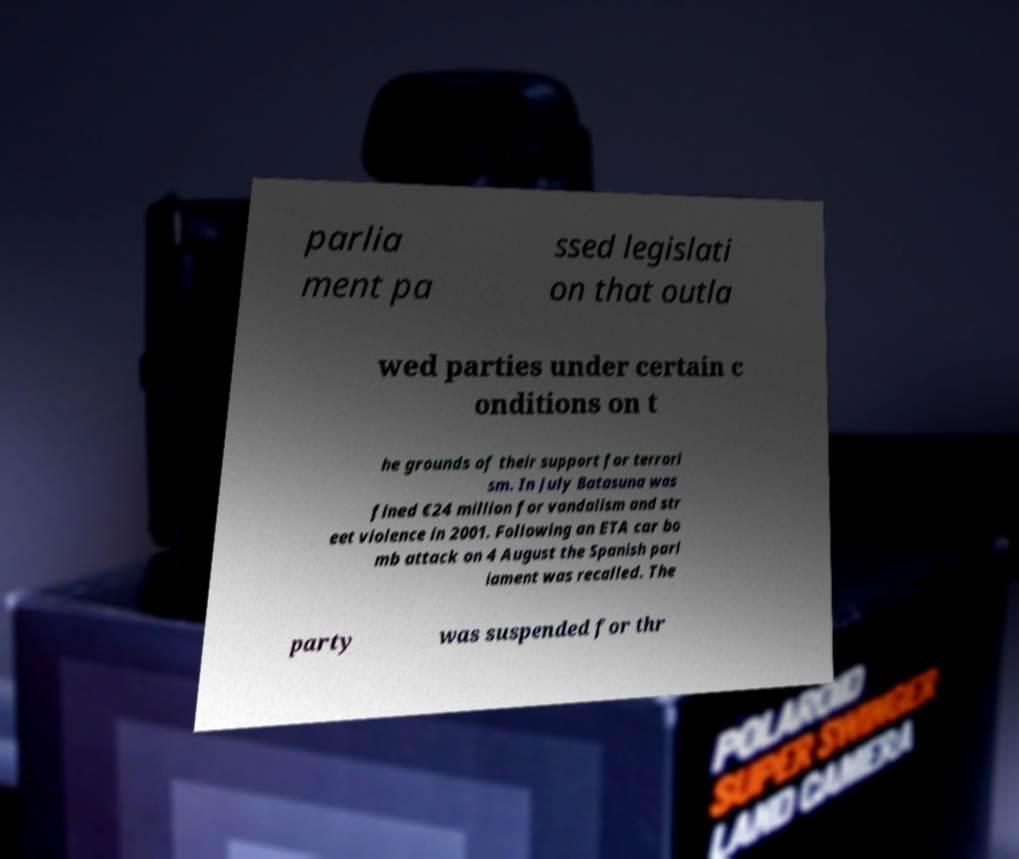Please read and relay the text visible in this image. What does it say? parlia ment pa ssed legislati on that outla wed parties under certain c onditions on t he grounds of their support for terrori sm. In July Batasuna was fined €24 million for vandalism and str eet violence in 2001. Following an ETA car bo mb attack on 4 August the Spanish parl iament was recalled. The party was suspended for thr 